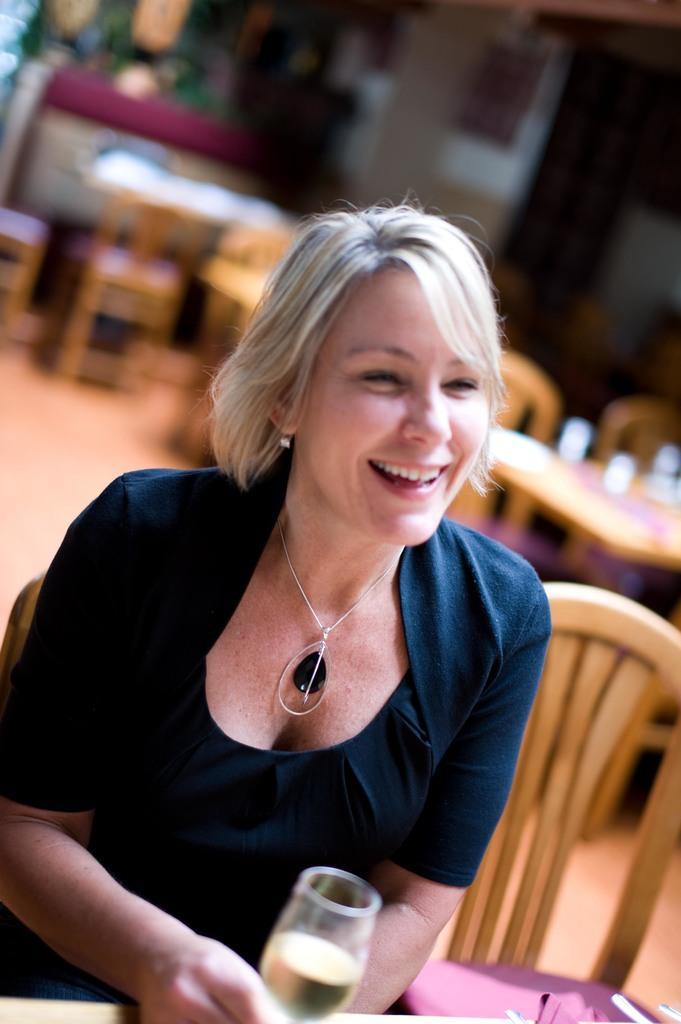Can you describe this image briefly? In the image we can see a woman sitting, wearing clothes, neck chain, earring and she is smiling. She is holding a wine glass in her hand. Here we can see chairs, tables and the background is blurred. 